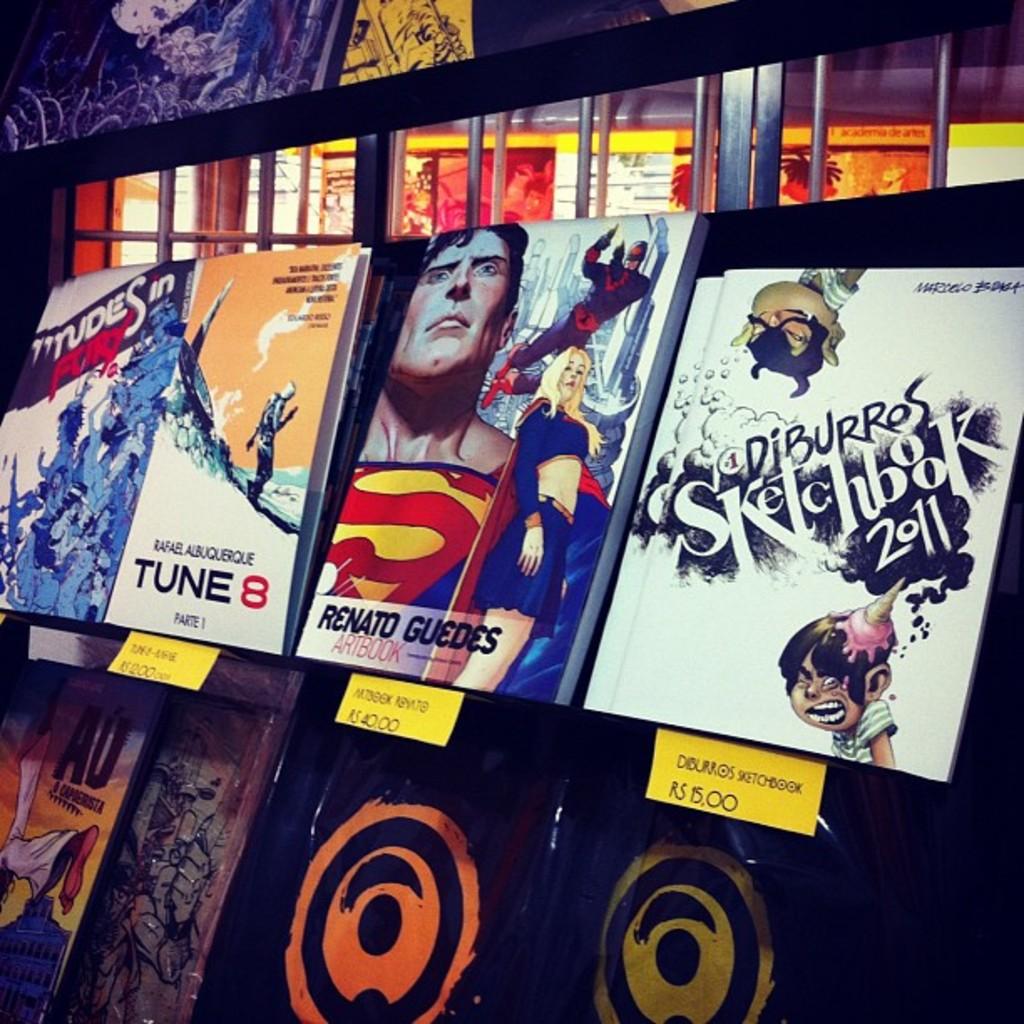What year is the right, white book from?
Ensure brevity in your answer.  2011. What is the red number?
Your response must be concise. 8. 